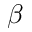<formula> <loc_0><loc_0><loc_500><loc_500>\beta</formula> 